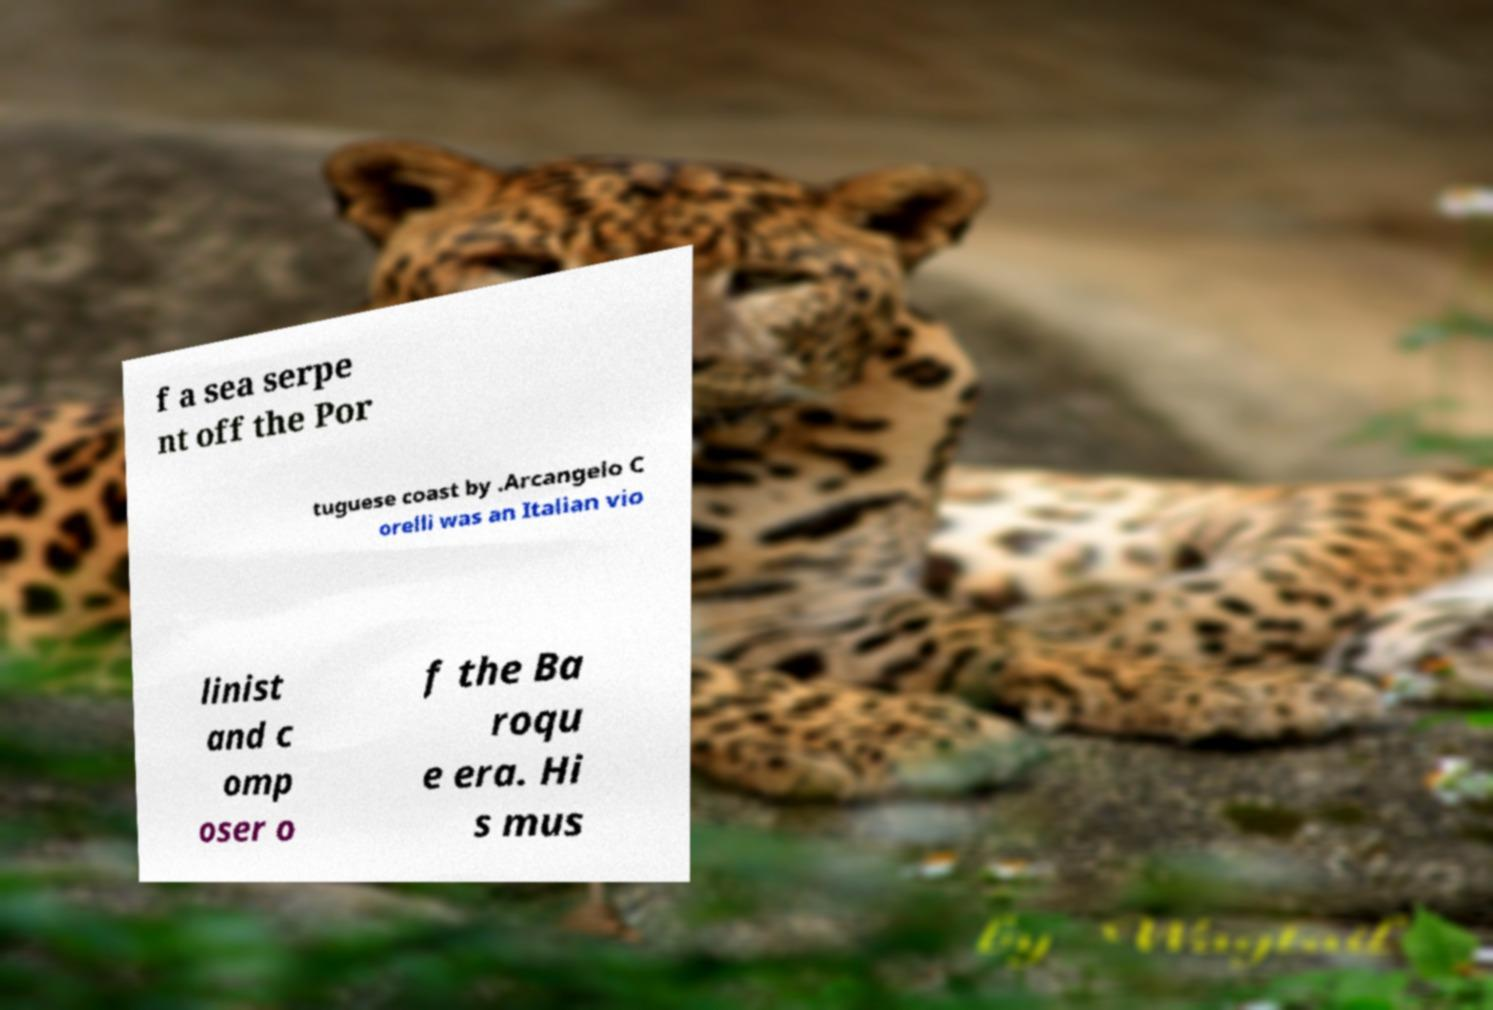Can you accurately transcribe the text from the provided image for me? f a sea serpe nt off the Por tuguese coast by .Arcangelo C orelli was an Italian vio linist and c omp oser o f the Ba roqu e era. Hi s mus 